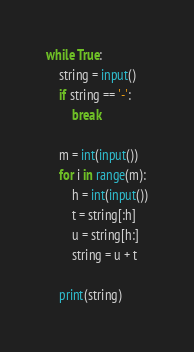Convert code to text. <code><loc_0><loc_0><loc_500><loc_500><_Python_>while True:
    string = input()
    if string == '-':
        break

    m = int(input())
    for i in range(m):
        h = int(input())
        t = string[:h]
        u = string[h:]
        string = u + t

    print(string)

</code> 